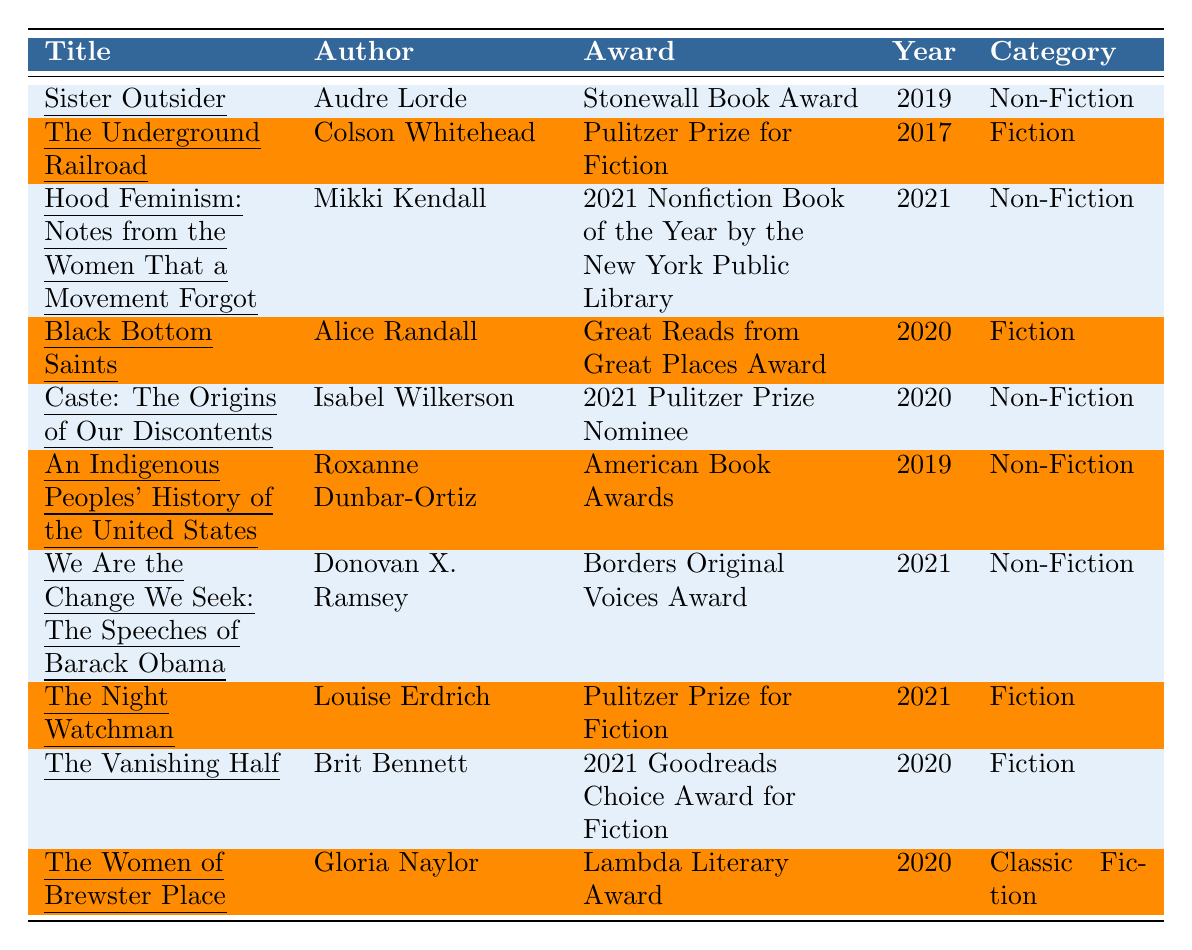What award did "Sister Outsider" win? The table lists that "Sister Outsider" won the Stonewall Book Award.
Answer: Stonewall Book Award Which book won the Pulitzer Prize for Fiction in 2021? The table shows that "The Night Watchman" is the book that received the Pulitzer Prize for Fiction in 2021.
Answer: The Night Watchman How many non-fiction books are listed in the table? The table contains five non-fiction books: "Sister Outsider," "Hood Feminism," "Caste," "An Indigenous Peoples' History," and "We Are the Change We Seek."
Answer: 5 Which author received an award in 2021 for their book? Several authors received awards in 2021: Mikki Kendall, Donovan X. Ramsey, and Louise Erdrich won awards for "Hood Feminism," "We Are the Change We Seek," and "The Night Watchman," respectively.
Answer: Mikki Kendall, Donovan X. Ramsey, Louise Erdrich What is the average year of the awards listed for the books? The years of the awards are 2019, 2017, 2021, 2020, 2020, 2019, 2021, 2021, 2020, and 2020. Summing these (2019 + 2017 + 2021 + 2020 + 2020 + 2019 + 2021 + 2021 + 2020 + 2020 = 2019) and dividing by 10 gives an average year of 2019.
Answer: 2019 Did "Caste: The Origins of Our Discontents" win any awards? The table indicates that "Caste: The Origins of Our Discontents" was nominated for the 2021 Pulitzer Prize but did not win any award according to the information provided.
Answer: No How many different categories of books are listed in the table? The table includes four categories: Non-Fiction, Fiction, and Classic Fiction, appearing multiple times but counted as three distinct categories.
Answer: 3 What are the titles of the books recognized by the Lambda Literary Award? The only book in the table that received the Lambda Literary Award is "The Women of Brewster Place" authored by Gloria Naylor.
Answer: The Women of Brewster Place Which book was nominated for the 2021 Pulitzer Prize and when? The table specifies that "Caste: The Origins of Our Discontents" was a 2021 Pulitzer Prize Nominee in 2020.
Answer: Caste: The Origins of Our Discontents (2020) What is the total number of unique authors listed in the table? The authors listed are Audre Lorde, Colson Whitehead, Mikki Kendall, Alice Randall, Isabel Wilkerson, Roxanne Dunbar-Ortiz, Donovan X. Ramsey, Louise Erdrich, Brit Bennett, and Gloria Naylor, making a total of 10 unique authors.
Answer: 10 